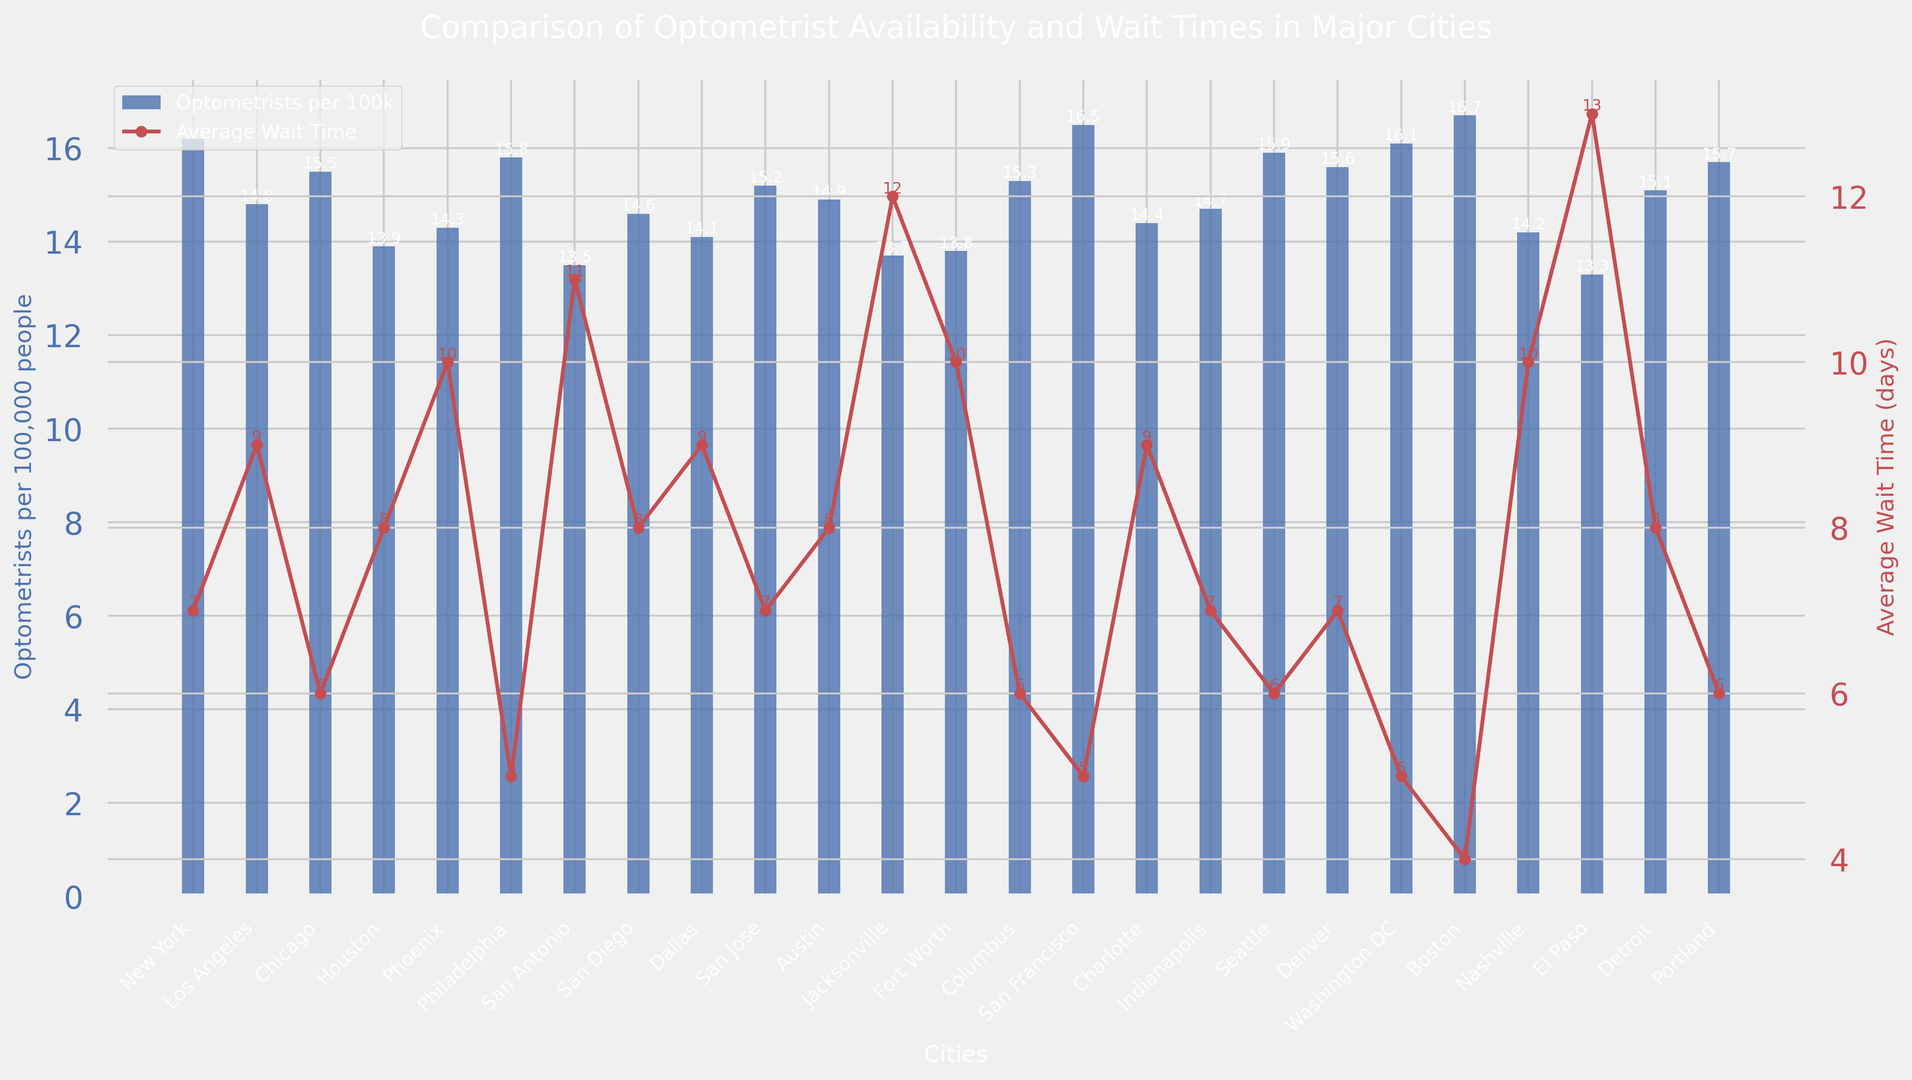What's the city with the highest number of optometrists per capita? By examining the bars representing optometrists per 100k for all cities, the highest bar corresponds to Boston.
Answer: Boston Which city has the shortest average wait time for an appointment? Reviewing the lines and markers for average wait times, Boston has the shortest wait time of 4 days.
Answer: Boston How much greater is the number of optometrists per capita in San Francisco compared to El Paso? San Francisco has 16.5 optometrists per 100k while El Paso has 13.3. The difference is 16.5 - 13.3 = 3.2.
Answer: 3.2 What is the average wait time in cities with optometrists per capita above 16 per 100k? The cities with optometrists per capita above 16 are New York (16.2), San Francisco (16.5), Seattle (15.9), Washington DC (16.1), and Boston (16.7). Their wait times are 7, 5, 6, 5, and 4 respectively. The average is (7+5+6+5+4)/5 = 5.4 days.
Answer: 5.4 days Which city has the lowest number of optometrists per capita and what is its average wait time? The lowest bar corresponds to El Paso with 13.3 optometrists per 100k. Its corresponding wait time line shows 13 days.
Answer: El Paso, 13 days Is there any city where the number of optometrists per capita and the average wait time are both the same? By comparing both values visually for each city, no city has the same value for both metrics.
Answer: No How does the wait time in Philadelphia compare to the wait time in Houston? Philadelphia has an average wait time of 5 days, and Houston has an average wait time of 8 days. Thus, Philadelphia's wait time is 3 days shorter than Houston's.
Answer: Philadelphia has a 3 days shorter wait time than Houston What's the sum of optometrists per 100k in Austin and Dallas? Austin has 14.9 optometrists per 100k and Dallas has 14.1. The sum is 14.9 + 14.1 = 29.
Answer: 29 In terms of optometrists per capita, which city is closest to the average of all cities? First, calculate the average optometrists per 100k for all cities. The sum of optometrists per 100k is 348.8 across 24 cities, so the average is 348.8/24 ≈ 14.53. The city closest to 14.53 is Austin with 14.9.
Answer: Austin Which city has a longer wait time, Phoenix or Fort Worth? Phoenix has an average wait time of 10 days, and Fort Worth also has an average wait time of 10 days. Therefore, both cities have the same wait time.
Answer: Phoenix and Fort Worth both have the same wait time 